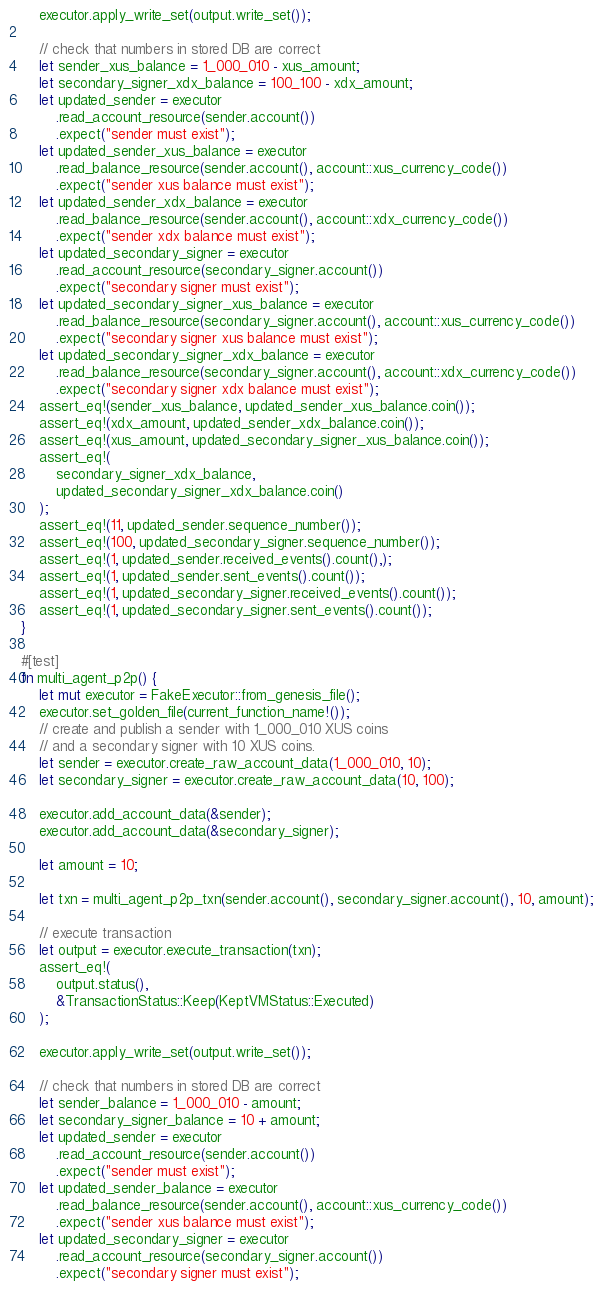<code> <loc_0><loc_0><loc_500><loc_500><_Rust_>
    executor.apply_write_set(output.write_set());

    // check that numbers in stored DB are correct
    let sender_xus_balance = 1_000_010 - xus_amount;
    let secondary_signer_xdx_balance = 100_100 - xdx_amount;
    let updated_sender = executor
        .read_account_resource(sender.account())
        .expect("sender must exist");
    let updated_sender_xus_balance = executor
        .read_balance_resource(sender.account(), account::xus_currency_code())
        .expect("sender xus balance must exist");
    let updated_sender_xdx_balance = executor
        .read_balance_resource(sender.account(), account::xdx_currency_code())
        .expect("sender xdx balance must exist");
    let updated_secondary_signer = executor
        .read_account_resource(secondary_signer.account())
        .expect("secondary signer must exist");
    let updated_secondary_signer_xus_balance = executor
        .read_balance_resource(secondary_signer.account(), account::xus_currency_code())
        .expect("secondary signer xus balance must exist");
    let updated_secondary_signer_xdx_balance = executor
        .read_balance_resource(secondary_signer.account(), account::xdx_currency_code())
        .expect("secondary signer xdx balance must exist");
    assert_eq!(sender_xus_balance, updated_sender_xus_balance.coin());
    assert_eq!(xdx_amount, updated_sender_xdx_balance.coin());
    assert_eq!(xus_amount, updated_secondary_signer_xus_balance.coin());
    assert_eq!(
        secondary_signer_xdx_balance,
        updated_secondary_signer_xdx_balance.coin()
    );
    assert_eq!(11, updated_sender.sequence_number());
    assert_eq!(100, updated_secondary_signer.sequence_number());
    assert_eq!(1, updated_sender.received_events().count(),);
    assert_eq!(1, updated_sender.sent_events().count());
    assert_eq!(1, updated_secondary_signer.received_events().count());
    assert_eq!(1, updated_secondary_signer.sent_events().count());
}

#[test]
fn multi_agent_p2p() {
    let mut executor = FakeExecutor::from_genesis_file();
    executor.set_golden_file(current_function_name!());
    // create and publish a sender with 1_000_010 XUS coins
    // and a secondary signer with 10 XUS coins.
    let sender = executor.create_raw_account_data(1_000_010, 10);
    let secondary_signer = executor.create_raw_account_data(10, 100);

    executor.add_account_data(&sender);
    executor.add_account_data(&secondary_signer);

    let amount = 10;

    let txn = multi_agent_p2p_txn(sender.account(), secondary_signer.account(), 10, amount);

    // execute transaction
    let output = executor.execute_transaction(txn);
    assert_eq!(
        output.status(),
        &TransactionStatus::Keep(KeptVMStatus::Executed)
    );

    executor.apply_write_set(output.write_set());

    // check that numbers in stored DB are correct
    let sender_balance = 1_000_010 - amount;
    let secondary_signer_balance = 10 + amount;
    let updated_sender = executor
        .read_account_resource(sender.account())
        .expect("sender must exist");
    let updated_sender_balance = executor
        .read_balance_resource(sender.account(), account::xus_currency_code())
        .expect("sender xus balance must exist");
    let updated_secondary_signer = executor
        .read_account_resource(secondary_signer.account())
        .expect("secondary signer must exist");</code> 